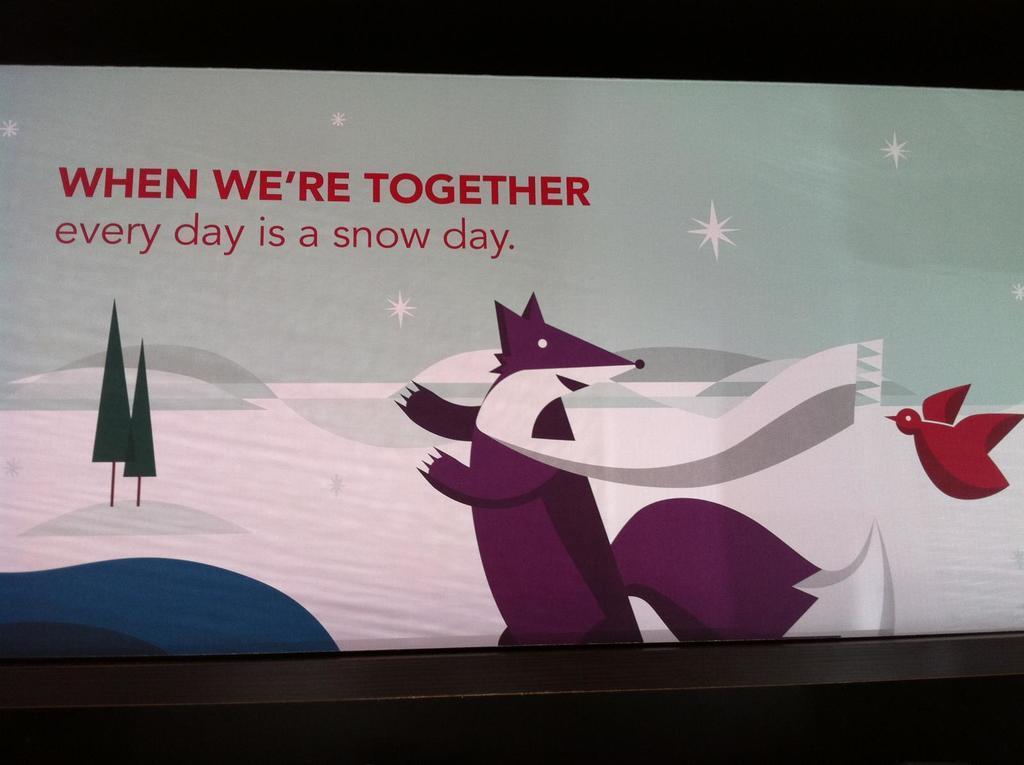How would you summarize this image in a sentence or two? In this image I can see a cartoon which is in purple color and bird which is in red color. I can see trees and background is in white and blue color. 